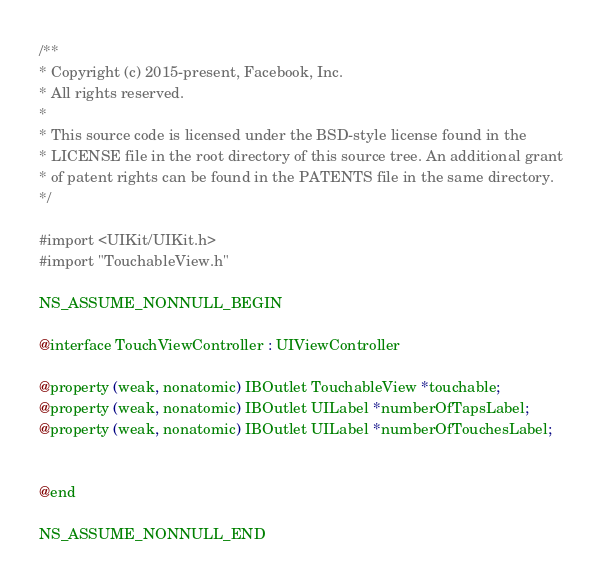Convert code to text. <code><loc_0><loc_0><loc_500><loc_500><_C_>/**
* Copyright (c) 2015-present, Facebook, Inc.
* All rights reserved.
*
* This source code is licensed under the BSD-style license found in the
* LICENSE file in the root directory of this source tree. An additional grant
* of patent rights can be found in the PATENTS file in the same directory.
*/

#import <UIKit/UIKit.h>
#import "TouchableView.h"

NS_ASSUME_NONNULL_BEGIN

@interface TouchViewController : UIViewController

@property (weak, nonatomic) IBOutlet TouchableView *touchable;
@property (weak, nonatomic) IBOutlet UILabel *numberOfTapsLabel;
@property (weak, nonatomic) IBOutlet UILabel *numberOfTouchesLabel;


@end

NS_ASSUME_NONNULL_END
</code> 